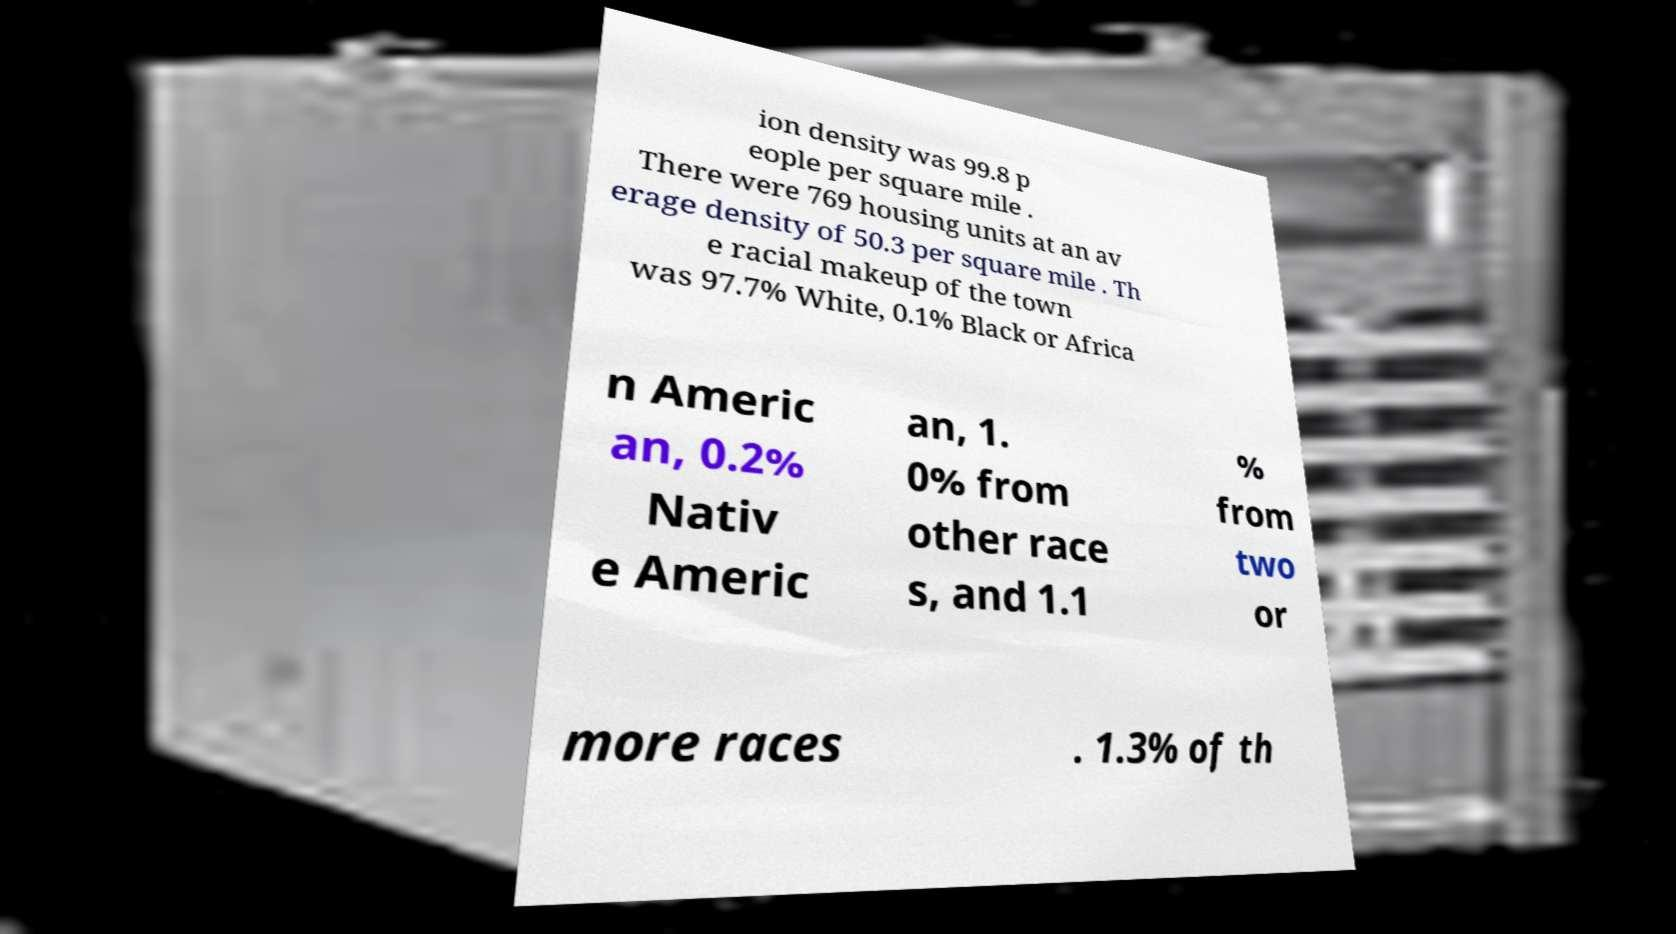Can you accurately transcribe the text from the provided image for me? ion density was 99.8 p eople per square mile . There were 769 housing units at an av erage density of 50.3 per square mile . Th e racial makeup of the town was 97.7% White, 0.1% Black or Africa n Americ an, 0.2% Nativ e Americ an, 1. 0% from other race s, and 1.1 % from two or more races . 1.3% of th 